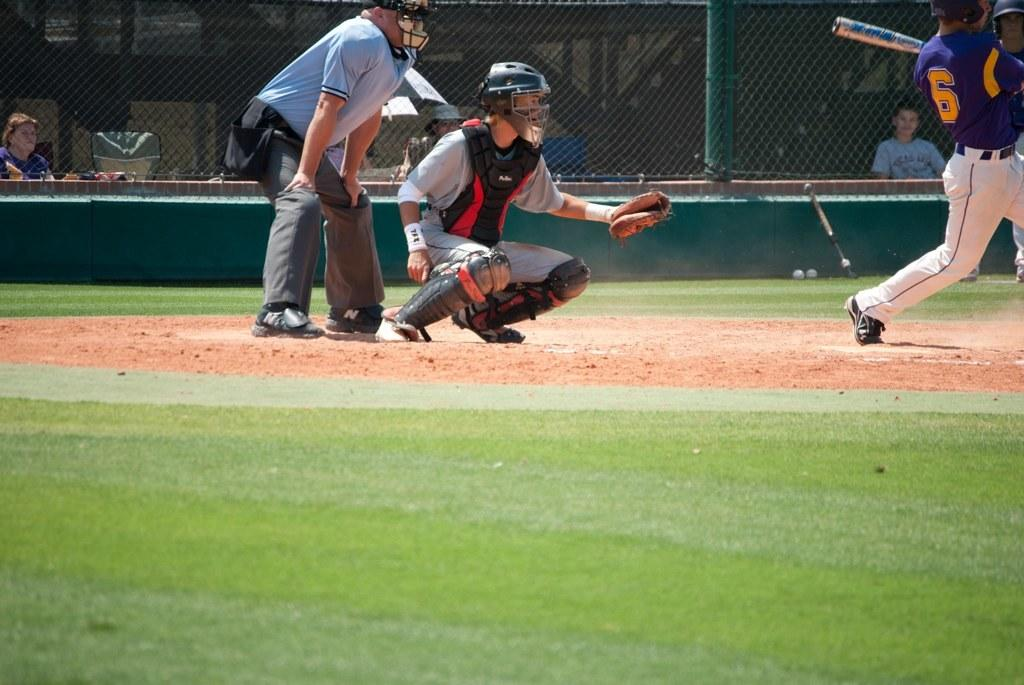What activity are the people in the image engaged in? The people in the image are playing a game. What can be seen in the background of the image? There is a mesh in the background of the image. How many people are visible in the background? There are two people in the background of the image. What is visible at the bottom of the image? The ground is visible at the bottom of the image. What type of toad can be seen hopping in the image? There is no toad present in the image; it features people playing a game. How does the memory of the game affect the players' performance? The provided facts do not mention anything about the players' memory or performance, so we cannot answer this question. 